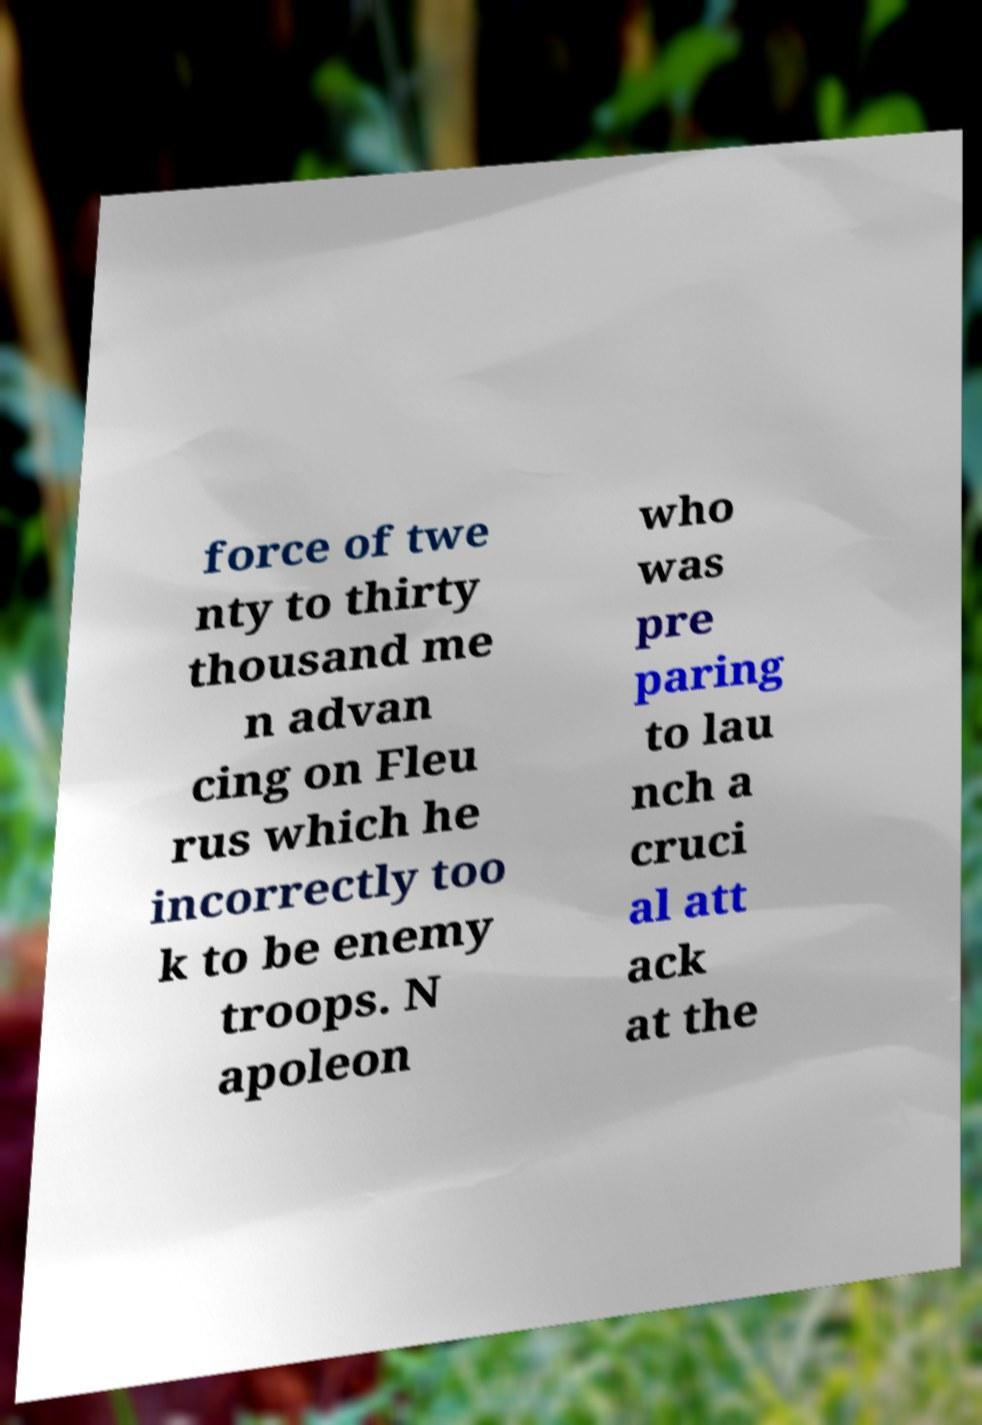Can you accurately transcribe the text from the provided image for me? force of twe nty to thirty thousand me n advan cing on Fleu rus which he incorrectly too k to be enemy troops. N apoleon who was pre paring to lau nch a cruci al att ack at the 